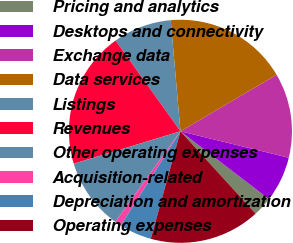Convert chart. <chart><loc_0><loc_0><loc_500><loc_500><pie_chart><fcel>Pricing and analytics<fcel>Desktops and connectivity<fcel>Exchange data<fcel>Data services<fcel>Listings<fcel>Revenues<fcel>Other operating expenses<fcel>Acquisition-related<fcel>Depreciation and amortization<fcel>Operating expenses<nl><fcel>2.82%<fcel>6.6%<fcel>12.27%<fcel>17.93%<fcel>8.49%<fcel>19.82%<fcel>10.38%<fcel>0.93%<fcel>4.71%<fcel>16.05%<nl></chart> 